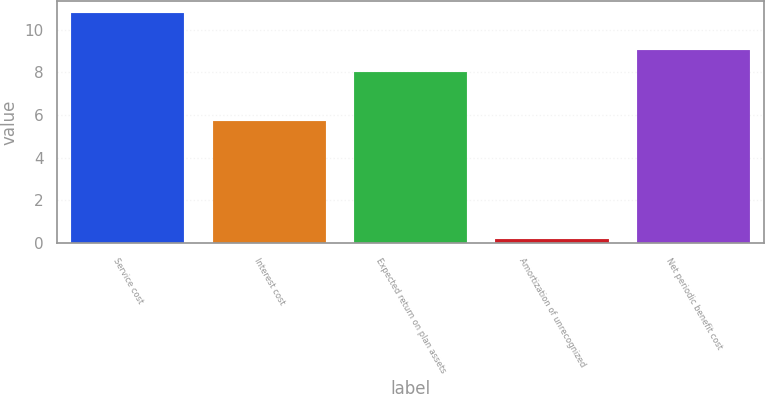Convert chart to OTSL. <chart><loc_0><loc_0><loc_500><loc_500><bar_chart><fcel>Service cost<fcel>Interest cost<fcel>Expected return on plan assets<fcel>Amortization of unrecognized<fcel>Net periodic benefit cost<nl><fcel>10.8<fcel>5.7<fcel>8<fcel>0.2<fcel>9.06<nl></chart> 